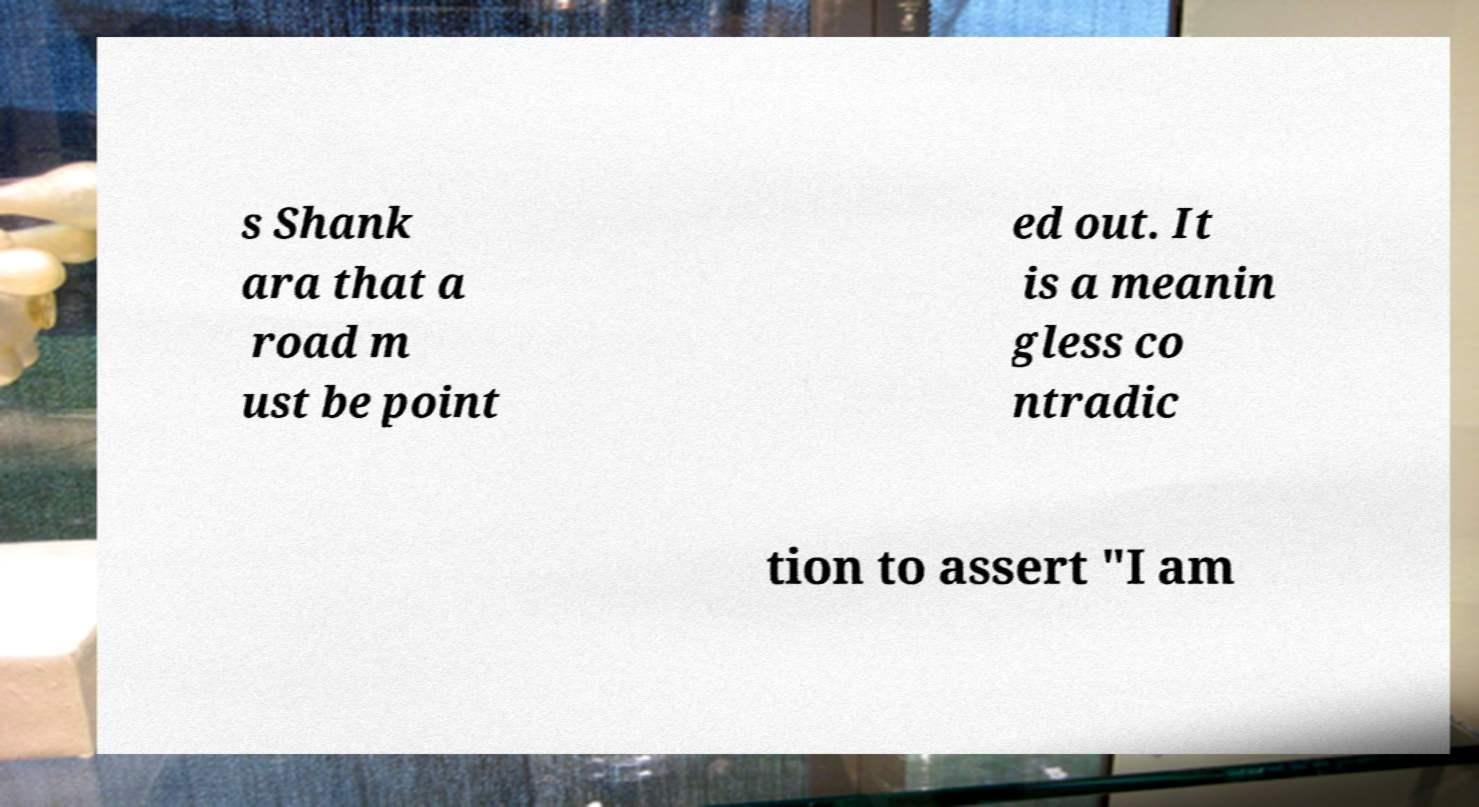Can you read and provide the text displayed in the image?This photo seems to have some interesting text. Can you extract and type it out for me? s Shank ara that a road m ust be point ed out. It is a meanin gless co ntradic tion to assert "I am 